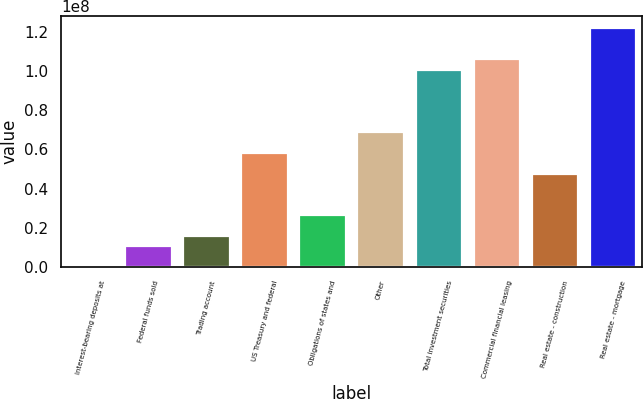Convert chart to OTSL. <chart><loc_0><loc_0><loc_500><loc_500><bar_chart><fcel>Interest-bearing deposits at<fcel>Federal funds sold<fcel>Trading account<fcel>US Treasury and federal<fcel>Obligations of states and<fcel>Other<fcel>Total investment securities<fcel>Commercial financial leasing<fcel>Real estate - construction<fcel>Real estate - mortgage<nl><fcel>10242<fcel>1.05959e+07<fcel>1.58888e+07<fcel>5.82316e+07<fcel>2.64745e+07<fcel>6.88173e+07<fcel>1.00574e+08<fcel>1.05867e+08<fcel>4.76459e+07<fcel>1.21746e+08<nl></chart> 